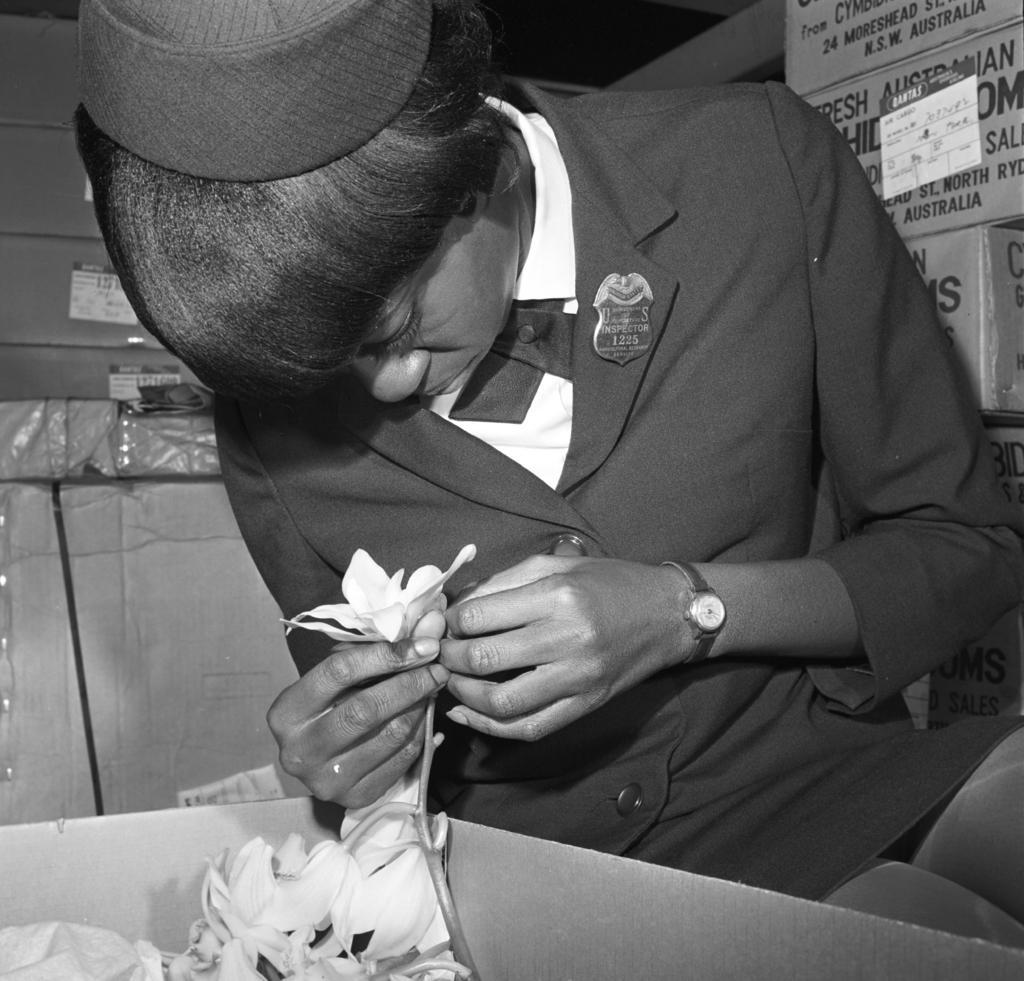Please provide a concise description of this image. In this image there is a person sitting and holding a flower, there are flowers in a cardboard box, and in the background there are cardboard boxes. 